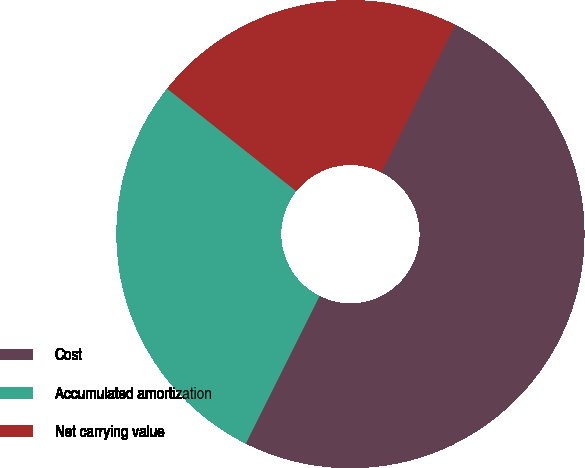Convert chart. <chart><loc_0><loc_0><loc_500><loc_500><pie_chart><fcel>Cost<fcel>Accumulated amortization<fcel>Net carrying value<nl><fcel>50.0%<fcel>28.3%<fcel>21.7%<nl></chart> 